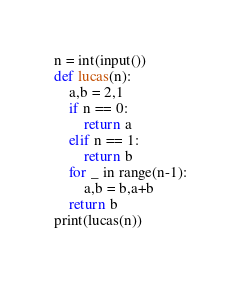Convert code to text. <code><loc_0><loc_0><loc_500><loc_500><_Python_>n = int(input())
def lucas(n):
    a,b = 2,1
    if n == 0:
        return a
    elif n == 1:
        return b
    for _ in range(n-1):
        a,b = b,a+b
    return b
print(lucas(n))</code> 